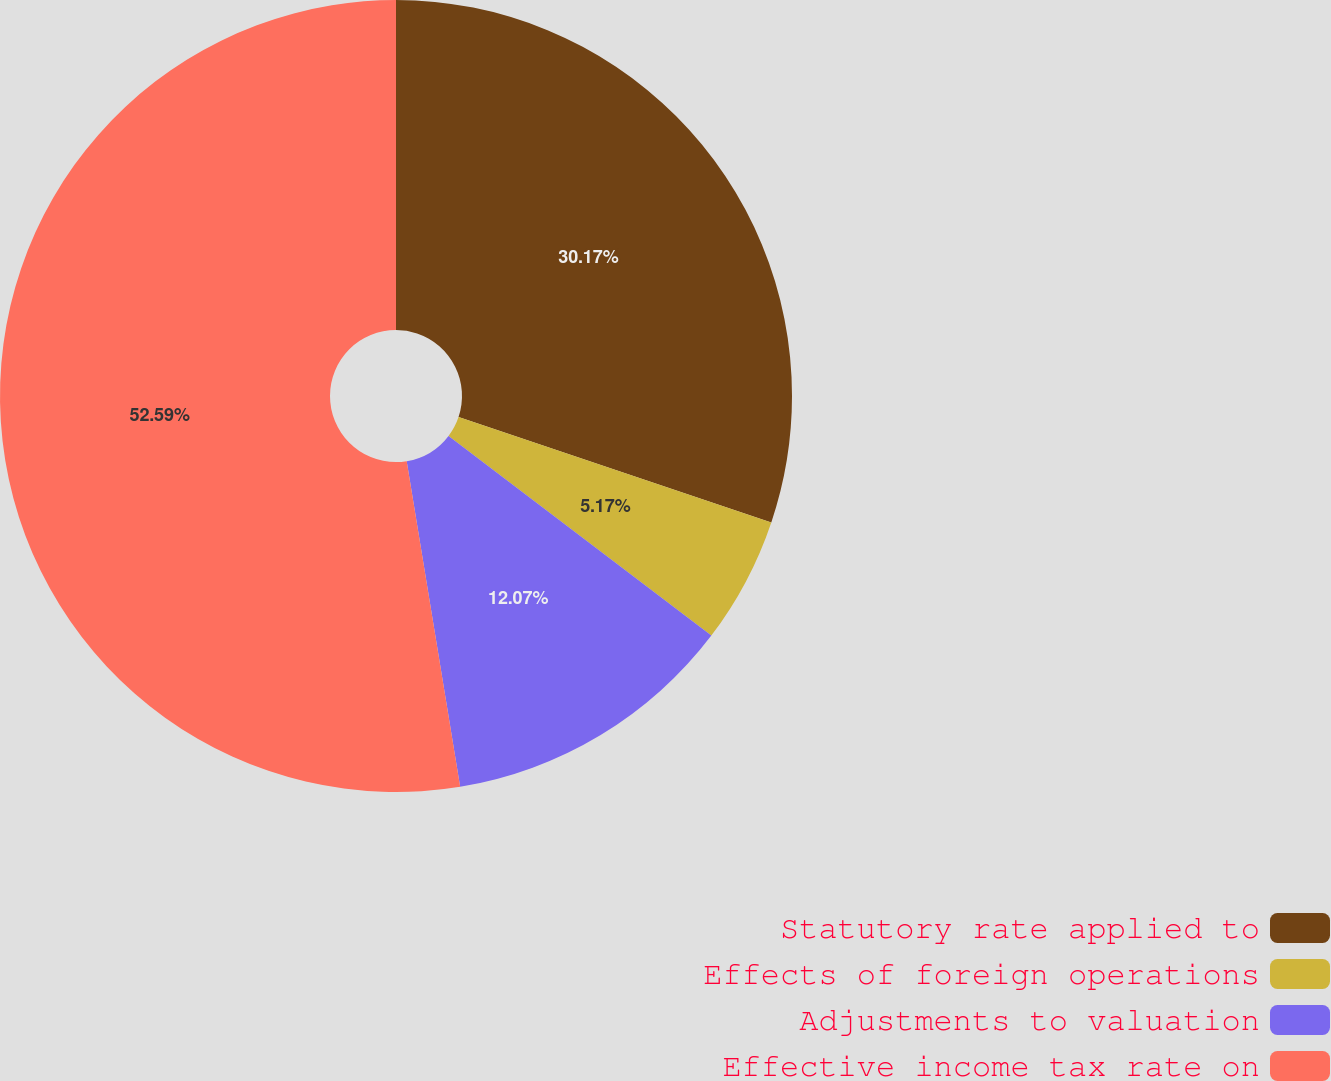Convert chart to OTSL. <chart><loc_0><loc_0><loc_500><loc_500><pie_chart><fcel>Statutory rate applied to<fcel>Effects of foreign operations<fcel>Adjustments to valuation<fcel>Effective income tax rate on<nl><fcel>30.17%<fcel>5.17%<fcel>12.07%<fcel>52.59%<nl></chart> 